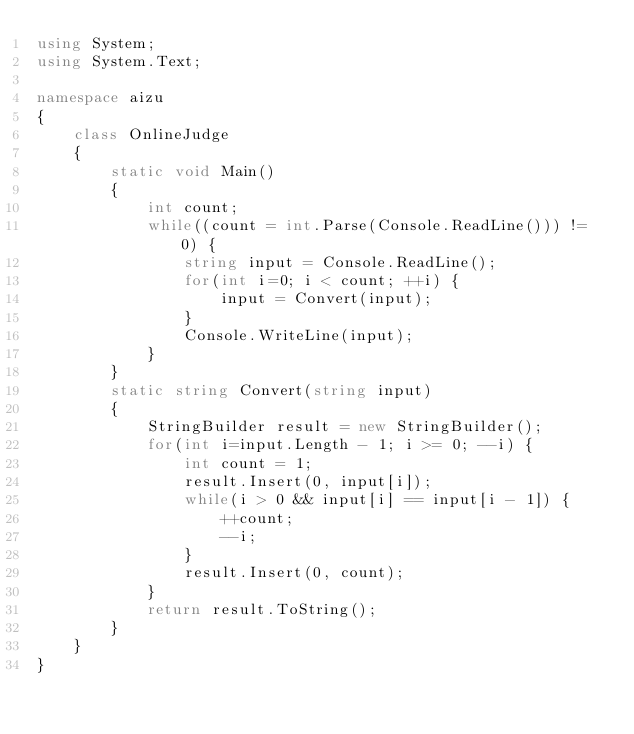<code> <loc_0><loc_0><loc_500><loc_500><_C#_>using System;
using System.Text;

namespace aizu
{
    class OnlineJudge
    {
        static void Main()
        {
            int count;
            while((count = int.Parse(Console.ReadLine())) != 0) {
                string input = Console.ReadLine();
                for(int i=0; i < count; ++i) {
                    input = Convert(input);
                }
                Console.WriteLine(input);
            }
        }
        static string Convert(string input)
        {
            StringBuilder result = new StringBuilder();
            for(int i=input.Length - 1; i >= 0; --i) {
                int count = 1;
                result.Insert(0, input[i]);
                while(i > 0 && input[i] == input[i - 1]) {
                    ++count;
                    --i;
                }
                result.Insert(0, count);
            }
            return result.ToString();
        }
    }
}</code> 